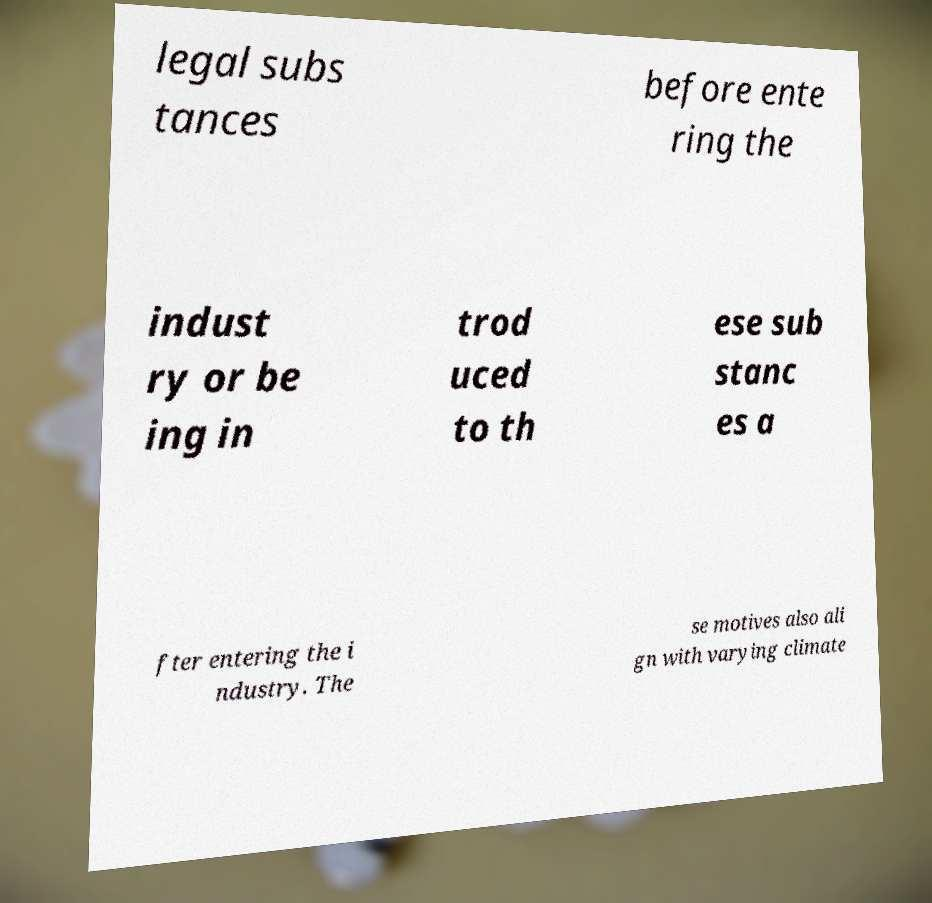What messages or text are displayed in this image? I need them in a readable, typed format. legal subs tances before ente ring the indust ry or be ing in trod uced to th ese sub stanc es a fter entering the i ndustry. The se motives also ali gn with varying climate 